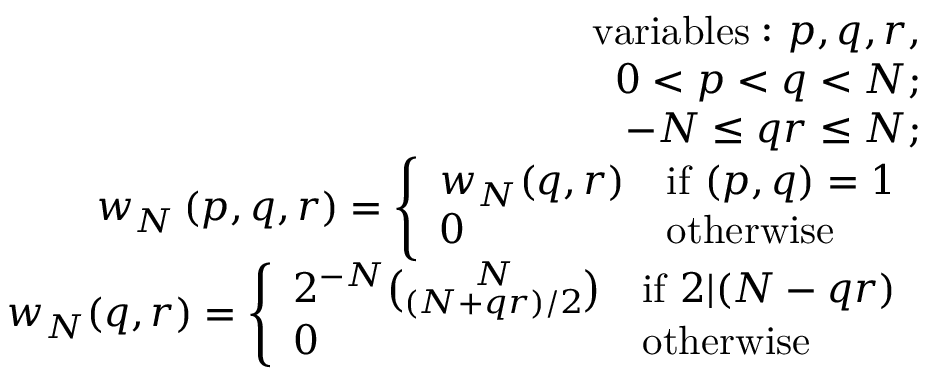<formula> <loc_0><loc_0><loc_500><loc_500>\begin{array} { r l r } & { v a r i a b l e s \colon p , q , r , } \\ & { 0 < p < q < N ; } \\ & { - N \leq q r \leq N ; } \\ & { w _ { N } \left ( p , q , r \right ) = \left \{ \begin{array} { l l } { w _ { N } ( q , r ) } & { i f ( p , q ) = 1 } \\ { 0 } & { o t h e r w i s e } \end{array} } \\ & { w _ { N } ( q , r ) = \left \{ \begin{array} { l l } { 2 ^ { - N } \binom { N } { ( N + q r ) / 2 } } & { i f 2 | ( N - q r ) } \\ { 0 } & { o t h e r w i s e } \end{array} } \end{array}</formula> 